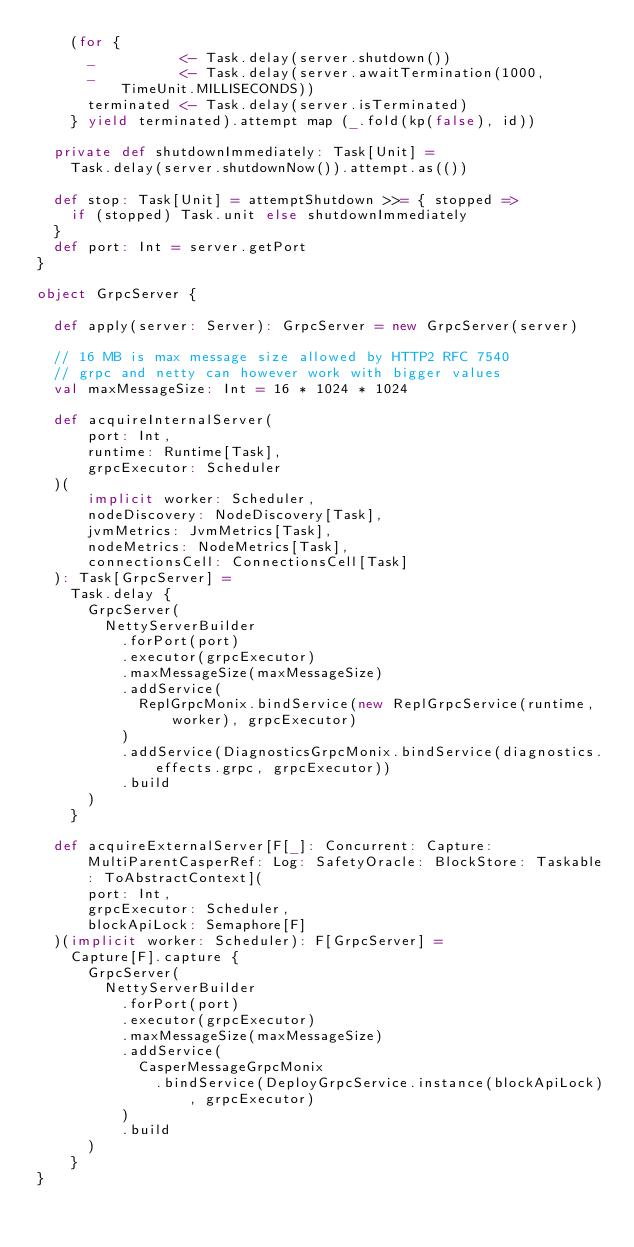Convert code to text. <code><loc_0><loc_0><loc_500><loc_500><_Scala_>    (for {
      _          <- Task.delay(server.shutdown())
      _          <- Task.delay(server.awaitTermination(1000, TimeUnit.MILLISECONDS))
      terminated <- Task.delay(server.isTerminated)
    } yield terminated).attempt map (_.fold(kp(false), id))

  private def shutdownImmediately: Task[Unit] =
    Task.delay(server.shutdownNow()).attempt.as(())

  def stop: Task[Unit] = attemptShutdown >>= { stopped =>
    if (stopped) Task.unit else shutdownImmediately
  }
  def port: Int = server.getPort
}

object GrpcServer {

  def apply(server: Server): GrpcServer = new GrpcServer(server)

  // 16 MB is max message size allowed by HTTP2 RFC 7540
  // grpc and netty can however work with bigger values
  val maxMessageSize: Int = 16 * 1024 * 1024

  def acquireInternalServer(
      port: Int,
      runtime: Runtime[Task],
      grpcExecutor: Scheduler
  )(
      implicit worker: Scheduler,
      nodeDiscovery: NodeDiscovery[Task],
      jvmMetrics: JvmMetrics[Task],
      nodeMetrics: NodeMetrics[Task],
      connectionsCell: ConnectionsCell[Task]
  ): Task[GrpcServer] =
    Task.delay {
      GrpcServer(
        NettyServerBuilder
          .forPort(port)
          .executor(grpcExecutor)
          .maxMessageSize(maxMessageSize)
          .addService(
            ReplGrpcMonix.bindService(new ReplGrpcService(runtime, worker), grpcExecutor)
          )
          .addService(DiagnosticsGrpcMonix.bindService(diagnostics.effects.grpc, grpcExecutor))
          .build
      )
    }

  def acquireExternalServer[F[_]: Concurrent: Capture: MultiParentCasperRef: Log: SafetyOracle: BlockStore: Taskable: ToAbstractContext](
      port: Int,
      grpcExecutor: Scheduler,
      blockApiLock: Semaphore[F]
  )(implicit worker: Scheduler): F[GrpcServer] =
    Capture[F].capture {
      GrpcServer(
        NettyServerBuilder
          .forPort(port)
          .executor(grpcExecutor)
          .maxMessageSize(maxMessageSize)
          .addService(
            CasperMessageGrpcMonix
              .bindService(DeployGrpcService.instance(blockApiLock), grpcExecutor)
          )
          .build
      )
    }
}
</code> 